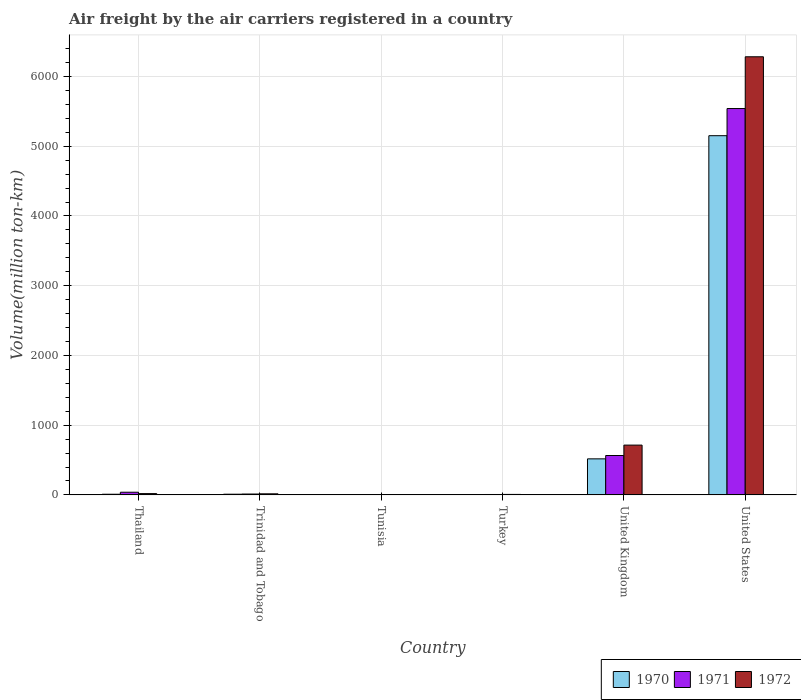How many different coloured bars are there?
Keep it short and to the point. 3. How many groups of bars are there?
Ensure brevity in your answer.  6. Are the number of bars per tick equal to the number of legend labels?
Make the answer very short. Yes. What is the label of the 3rd group of bars from the left?
Make the answer very short. Tunisia. What is the volume of the air carriers in 1971 in Trinidad and Tobago?
Provide a short and direct response. 12.6. Across all countries, what is the maximum volume of the air carriers in 1970?
Your answer should be very brief. 5151.2. Across all countries, what is the minimum volume of the air carriers in 1971?
Offer a very short reply. 1.6. In which country was the volume of the air carriers in 1972 minimum?
Give a very brief answer. Tunisia. What is the total volume of the air carriers in 1970 in the graph?
Keep it short and to the point. 5693.1. What is the difference between the volume of the air carriers in 1971 in Tunisia and that in United States?
Ensure brevity in your answer.  -5539.2. What is the difference between the volume of the air carriers in 1971 in United States and the volume of the air carriers in 1970 in Trinidad and Tobago?
Ensure brevity in your answer.  5531.1. What is the average volume of the air carriers in 1970 per country?
Give a very brief answer. 948.85. What is the difference between the volume of the air carriers of/in 1972 and volume of the air carriers of/in 1971 in United States?
Your answer should be very brief. 742.2. What is the ratio of the volume of the air carriers in 1970 in Turkey to that in United States?
Ensure brevity in your answer.  0. Is the volume of the air carriers in 1970 in Trinidad and Tobago less than that in Turkey?
Give a very brief answer. No. What is the difference between the highest and the second highest volume of the air carriers in 1972?
Your response must be concise. -695.5. What is the difference between the highest and the lowest volume of the air carriers in 1970?
Give a very brief answer. 5149.8. In how many countries, is the volume of the air carriers in 1970 greater than the average volume of the air carriers in 1970 taken over all countries?
Ensure brevity in your answer.  1. What does the 3rd bar from the right in Tunisia represents?
Keep it short and to the point. 1970. How many bars are there?
Your answer should be compact. 18. Are all the bars in the graph horizontal?
Your answer should be very brief. No. How many countries are there in the graph?
Your answer should be very brief. 6. Are the values on the major ticks of Y-axis written in scientific E-notation?
Offer a terse response. No. How are the legend labels stacked?
Your response must be concise. Horizontal. What is the title of the graph?
Your response must be concise. Air freight by the air carriers registered in a country. What is the label or title of the X-axis?
Provide a succinct answer. Country. What is the label or title of the Y-axis?
Ensure brevity in your answer.  Volume(million ton-km). What is the Volume(million ton-km) in 1970 in Thailand?
Your answer should be very brief. 9.3. What is the Volume(million ton-km) of 1971 in Thailand?
Your answer should be compact. 38.3. What is the Volume(million ton-km) in 1972 in Thailand?
Ensure brevity in your answer.  18.6. What is the Volume(million ton-km) in 1970 in Trinidad and Tobago?
Offer a very short reply. 9.7. What is the Volume(million ton-km) of 1971 in Trinidad and Tobago?
Make the answer very short. 12.6. What is the Volume(million ton-km) in 1972 in Trinidad and Tobago?
Keep it short and to the point. 15.3. What is the Volume(million ton-km) in 1970 in Tunisia?
Your response must be concise. 1.4. What is the Volume(million ton-km) of 1971 in Tunisia?
Keep it short and to the point. 1.6. What is the Volume(million ton-km) of 1972 in Tunisia?
Offer a terse response. 2.8. What is the Volume(million ton-km) of 1970 in Turkey?
Offer a terse response. 4.6. What is the Volume(million ton-km) in 1971 in Turkey?
Your response must be concise. 5.7. What is the Volume(million ton-km) in 1972 in Turkey?
Give a very brief answer. 6.8. What is the Volume(million ton-km) of 1970 in United Kingdom?
Offer a very short reply. 516.9. What is the Volume(million ton-km) of 1971 in United Kingdom?
Keep it short and to the point. 564.9. What is the Volume(million ton-km) of 1972 in United Kingdom?
Make the answer very short. 714.1. What is the Volume(million ton-km) of 1970 in United States?
Keep it short and to the point. 5151.2. What is the Volume(million ton-km) of 1971 in United States?
Ensure brevity in your answer.  5540.8. What is the Volume(million ton-km) in 1972 in United States?
Offer a very short reply. 6283. Across all countries, what is the maximum Volume(million ton-km) in 1970?
Provide a short and direct response. 5151.2. Across all countries, what is the maximum Volume(million ton-km) in 1971?
Provide a succinct answer. 5540.8. Across all countries, what is the maximum Volume(million ton-km) in 1972?
Make the answer very short. 6283. Across all countries, what is the minimum Volume(million ton-km) in 1970?
Provide a succinct answer. 1.4. Across all countries, what is the minimum Volume(million ton-km) of 1971?
Offer a terse response. 1.6. Across all countries, what is the minimum Volume(million ton-km) of 1972?
Make the answer very short. 2.8. What is the total Volume(million ton-km) in 1970 in the graph?
Your response must be concise. 5693.1. What is the total Volume(million ton-km) in 1971 in the graph?
Offer a terse response. 6163.9. What is the total Volume(million ton-km) in 1972 in the graph?
Keep it short and to the point. 7040.6. What is the difference between the Volume(million ton-km) in 1971 in Thailand and that in Trinidad and Tobago?
Your answer should be compact. 25.7. What is the difference between the Volume(million ton-km) of 1972 in Thailand and that in Trinidad and Tobago?
Your answer should be compact. 3.3. What is the difference between the Volume(million ton-km) in 1970 in Thailand and that in Tunisia?
Provide a short and direct response. 7.9. What is the difference between the Volume(million ton-km) in 1971 in Thailand and that in Tunisia?
Offer a very short reply. 36.7. What is the difference between the Volume(million ton-km) in 1970 in Thailand and that in Turkey?
Provide a short and direct response. 4.7. What is the difference between the Volume(million ton-km) of 1971 in Thailand and that in Turkey?
Provide a short and direct response. 32.6. What is the difference between the Volume(million ton-km) of 1970 in Thailand and that in United Kingdom?
Give a very brief answer. -507.6. What is the difference between the Volume(million ton-km) of 1971 in Thailand and that in United Kingdom?
Your response must be concise. -526.6. What is the difference between the Volume(million ton-km) in 1972 in Thailand and that in United Kingdom?
Make the answer very short. -695.5. What is the difference between the Volume(million ton-km) of 1970 in Thailand and that in United States?
Offer a very short reply. -5141.9. What is the difference between the Volume(million ton-km) of 1971 in Thailand and that in United States?
Provide a succinct answer. -5502.5. What is the difference between the Volume(million ton-km) in 1972 in Thailand and that in United States?
Provide a succinct answer. -6264.4. What is the difference between the Volume(million ton-km) of 1972 in Trinidad and Tobago and that in Tunisia?
Provide a short and direct response. 12.5. What is the difference between the Volume(million ton-km) in 1971 in Trinidad and Tobago and that in Turkey?
Provide a succinct answer. 6.9. What is the difference between the Volume(million ton-km) of 1972 in Trinidad and Tobago and that in Turkey?
Your answer should be compact. 8.5. What is the difference between the Volume(million ton-km) in 1970 in Trinidad and Tobago and that in United Kingdom?
Give a very brief answer. -507.2. What is the difference between the Volume(million ton-km) of 1971 in Trinidad and Tobago and that in United Kingdom?
Offer a very short reply. -552.3. What is the difference between the Volume(million ton-km) in 1972 in Trinidad and Tobago and that in United Kingdom?
Give a very brief answer. -698.8. What is the difference between the Volume(million ton-km) in 1970 in Trinidad and Tobago and that in United States?
Your answer should be very brief. -5141.5. What is the difference between the Volume(million ton-km) in 1971 in Trinidad and Tobago and that in United States?
Your answer should be very brief. -5528.2. What is the difference between the Volume(million ton-km) of 1972 in Trinidad and Tobago and that in United States?
Offer a very short reply. -6267.7. What is the difference between the Volume(million ton-km) in 1970 in Tunisia and that in Turkey?
Keep it short and to the point. -3.2. What is the difference between the Volume(million ton-km) in 1971 in Tunisia and that in Turkey?
Keep it short and to the point. -4.1. What is the difference between the Volume(million ton-km) of 1970 in Tunisia and that in United Kingdom?
Make the answer very short. -515.5. What is the difference between the Volume(million ton-km) in 1971 in Tunisia and that in United Kingdom?
Ensure brevity in your answer.  -563.3. What is the difference between the Volume(million ton-km) of 1972 in Tunisia and that in United Kingdom?
Give a very brief answer. -711.3. What is the difference between the Volume(million ton-km) in 1970 in Tunisia and that in United States?
Your response must be concise. -5149.8. What is the difference between the Volume(million ton-km) in 1971 in Tunisia and that in United States?
Ensure brevity in your answer.  -5539.2. What is the difference between the Volume(million ton-km) of 1972 in Tunisia and that in United States?
Give a very brief answer. -6280.2. What is the difference between the Volume(million ton-km) of 1970 in Turkey and that in United Kingdom?
Give a very brief answer. -512.3. What is the difference between the Volume(million ton-km) in 1971 in Turkey and that in United Kingdom?
Provide a succinct answer. -559.2. What is the difference between the Volume(million ton-km) of 1972 in Turkey and that in United Kingdom?
Offer a very short reply. -707.3. What is the difference between the Volume(million ton-km) in 1970 in Turkey and that in United States?
Provide a succinct answer. -5146.6. What is the difference between the Volume(million ton-km) in 1971 in Turkey and that in United States?
Your response must be concise. -5535.1. What is the difference between the Volume(million ton-km) of 1972 in Turkey and that in United States?
Make the answer very short. -6276.2. What is the difference between the Volume(million ton-km) of 1970 in United Kingdom and that in United States?
Ensure brevity in your answer.  -4634.3. What is the difference between the Volume(million ton-km) in 1971 in United Kingdom and that in United States?
Ensure brevity in your answer.  -4975.9. What is the difference between the Volume(million ton-km) in 1972 in United Kingdom and that in United States?
Provide a succinct answer. -5568.9. What is the difference between the Volume(million ton-km) in 1971 in Thailand and the Volume(million ton-km) in 1972 in Trinidad and Tobago?
Your response must be concise. 23. What is the difference between the Volume(million ton-km) in 1970 in Thailand and the Volume(million ton-km) in 1972 in Tunisia?
Your response must be concise. 6.5. What is the difference between the Volume(million ton-km) in 1971 in Thailand and the Volume(million ton-km) in 1972 in Tunisia?
Your answer should be compact. 35.5. What is the difference between the Volume(million ton-km) of 1970 in Thailand and the Volume(million ton-km) of 1971 in Turkey?
Your response must be concise. 3.6. What is the difference between the Volume(million ton-km) of 1971 in Thailand and the Volume(million ton-km) of 1972 in Turkey?
Offer a terse response. 31.5. What is the difference between the Volume(million ton-km) in 1970 in Thailand and the Volume(million ton-km) in 1971 in United Kingdom?
Provide a short and direct response. -555.6. What is the difference between the Volume(million ton-km) in 1970 in Thailand and the Volume(million ton-km) in 1972 in United Kingdom?
Your answer should be very brief. -704.8. What is the difference between the Volume(million ton-km) of 1971 in Thailand and the Volume(million ton-km) of 1972 in United Kingdom?
Provide a succinct answer. -675.8. What is the difference between the Volume(million ton-km) of 1970 in Thailand and the Volume(million ton-km) of 1971 in United States?
Ensure brevity in your answer.  -5531.5. What is the difference between the Volume(million ton-km) of 1970 in Thailand and the Volume(million ton-km) of 1972 in United States?
Provide a succinct answer. -6273.7. What is the difference between the Volume(million ton-km) in 1971 in Thailand and the Volume(million ton-km) in 1972 in United States?
Make the answer very short. -6244.7. What is the difference between the Volume(million ton-km) in 1971 in Trinidad and Tobago and the Volume(million ton-km) in 1972 in Turkey?
Provide a short and direct response. 5.8. What is the difference between the Volume(million ton-km) in 1970 in Trinidad and Tobago and the Volume(million ton-km) in 1971 in United Kingdom?
Keep it short and to the point. -555.2. What is the difference between the Volume(million ton-km) of 1970 in Trinidad and Tobago and the Volume(million ton-km) of 1972 in United Kingdom?
Ensure brevity in your answer.  -704.4. What is the difference between the Volume(million ton-km) in 1971 in Trinidad and Tobago and the Volume(million ton-km) in 1972 in United Kingdom?
Provide a succinct answer. -701.5. What is the difference between the Volume(million ton-km) of 1970 in Trinidad and Tobago and the Volume(million ton-km) of 1971 in United States?
Your response must be concise. -5531.1. What is the difference between the Volume(million ton-km) in 1970 in Trinidad and Tobago and the Volume(million ton-km) in 1972 in United States?
Give a very brief answer. -6273.3. What is the difference between the Volume(million ton-km) of 1971 in Trinidad and Tobago and the Volume(million ton-km) of 1972 in United States?
Provide a succinct answer. -6270.4. What is the difference between the Volume(million ton-km) in 1970 in Tunisia and the Volume(million ton-km) in 1972 in Turkey?
Give a very brief answer. -5.4. What is the difference between the Volume(million ton-km) of 1970 in Tunisia and the Volume(million ton-km) of 1971 in United Kingdom?
Your answer should be very brief. -563.5. What is the difference between the Volume(million ton-km) of 1970 in Tunisia and the Volume(million ton-km) of 1972 in United Kingdom?
Your answer should be compact. -712.7. What is the difference between the Volume(million ton-km) in 1971 in Tunisia and the Volume(million ton-km) in 1972 in United Kingdom?
Your answer should be very brief. -712.5. What is the difference between the Volume(million ton-km) of 1970 in Tunisia and the Volume(million ton-km) of 1971 in United States?
Ensure brevity in your answer.  -5539.4. What is the difference between the Volume(million ton-km) of 1970 in Tunisia and the Volume(million ton-km) of 1972 in United States?
Make the answer very short. -6281.6. What is the difference between the Volume(million ton-km) in 1971 in Tunisia and the Volume(million ton-km) in 1972 in United States?
Offer a very short reply. -6281.4. What is the difference between the Volume(million ton-km) in 1970 in Turkey and the Volume(million ton-km) in 1971 in United Kingdom?
Provide a succinct answer. -560.3. What is the difference between the Volume(million ton-km) of 1970 in Turkey and the Volume(million ton-km) of 1972 in United Kingdom?
Give a very brief answer. -709.5. What is the difference between the Volume(million ton-km) in 1971 in Turkey and the Volume(million ton-km) in 1972 in United Kingdom?
Give a very brief answer. -708.4. What is the difference between the Volume(million ton-km) of 1970 in Turkey and the Volume(million ton-km) of 1971 in United States?
Your answer should be very brief. -5536.2. What is the difference between the Volume(million ton-km) in 1970 in Turkey and the Volume(million ton-km) in 1972 in United States?
Keep it short and to the point. -6278.4. What is the difference between the Volume(million ton-km) of 1971 in Turkey and the Volume(million ton-km) of 1972 in United States?
Provide a short and direct response. -6277.3. What is the difference between the Volume(million ton-km) in 1970 in United Kingdom and the Volume(million ton-km) in 1971 in United States?
Provide a short and direct response. -5023.9. What is the difference between the Volume(million ton-km) in 1970 in United Kingdom and the Volume(million ton-km) in 1972 in United States?
Your answer should be very brief. -5766.1. What is the difference between the Volume(million ton-km) of 1971 in United Kingdom and the Volume(million ton-km) of 1972 in United States?
Your answer should be very brief. -5718.1. What is the average Volume(million ton-km) of 1970 per country?
Your answer should be very brief. 948.85. What is the average Volume(million ton-km) in 1971 per country?
Your answer should be very brief. 1027.32. What is the average Volume(million ton-km) of 1972 per country?
Offer a terse response. 1173.43. What is the difference between the Volume(million ton-km) of 1971 and Volume(million ton-km) of 1972 in Thailand?
Your answer should be very brief. 19.7. What is the difference between the Volume(million ton-km) of 1970 and Volume(million ton-km) of 1971 in Trinidad and Tobago?
Provide a succinct answer. -2.9. What is the difference between the Volume(million ton-km) of 1970 and Volume(million ton-km) of 1972 in Trinidad and Tobago?
Your answer should be compact. -5.6. What is the difference between the Volume(million ton-km) in 1970 and Volume(million ton-km) in 1972 in Turkey?
Offer a very short reply. -2.2. What is the difference between the Volume(million ton-km) of 1970 and Volume(million ton-km) of 1971 in United Kingdom?
Provide a short and direct response. -48. What is the difference between the Volume(million ton-km) of 1970 and Volume(million ton-km) of 1972 in United Kingdom?
Keep it short and to the point. -197.2. What is the difference between the Volume(million ton-km) of 1971 and Volume(million ton-km) of 1972 in United Kingdom?
Keep it short and to the point. -149.2. What is the difference between the Volume(million ton-km) in 1970 and Volume(million ton-km) in 1971 in United States?
Provide a short and direct response. -389.6. What is the difference between the Volume(million ton-km) of 1970 and Volume(million ton-km) of 1972 in United States?
Ensure brevity in your answer.  -1131.8. What is the difference between the Volume(million ton-km) of 1971 and Volume(million ton-km) of 1972 in United States?
Keep it short and to the point. -742.2. What is the ratio of the Volume(million ton-km) in 1970 in Thailand to that in Trinidad and Tobago?
Give a very brief answer. 0.96. What is the ratio of the Volume(million ton-km) of 1971 in Thailand to that in Trinidad and Tobago?
Your answer should be compact. 3.04. What is the ratio of the Volume(million ton-km) in 1972 in Thailand to that in Trinidad and Tobago?
Give a very brief answer. 1.22. What is the ratio of the Volume(million ton-km) in 1970 in Thailand to that in Tunisia?
Give a very brief answer. 6.64. What is the ratio of the Volume(million ton-km) of 1971 in Thailand to that in Tunisia?
Your answer should be compact. 23.94. What is the ratio of the Volume(million ton-km) of 1972 in Thailand to that in Tunisia?
Offer a very short reply. 6.64. What is the ratio of the Volume(million ton-km) of 1970 in Thailand to that in Turkey?
Your answer should be very brief. 2.02. What is the ratio of the Volume(million ton-km) in 1971 in Thailand to that in Turkey?
Provide a succinct answer. 6.72. What is the ratio of the Volume(million ton-km) of 1972 in Thailand to that in Turkey?
Offer a very short reply. 2.74. What is the ratio of the Volume(million ton-km) of 1970 in Thailand to that in United Kingdom?
Ensure brevity in your answer.  0.02. What is the ratio of the Volume(million ton-km) of 1971 in Thailand to that in United Kingdom?
Offer a very short reply. 0.07. What is the ratio of the Volume(million ton-km) of 1972 in Thailand to that in United Kingdom?
Your answer should be compact. 0.03. What is the ratio of the Volume(million ton-km) of 1970 in Thailand to that in United States?
Ensure brevity in your answer.  0. What is the ratio of the Volume(million ton-km) in 1971 in Thailand to that in United States?
Ensure brevity in your answer.  0.01. What is the ratio of the Volume(million ton-km) of 1972 in Thailand to that in United States?
Provide a succinct answer. 0. What is the ratio of the Volume(million ton-km) in 1970 in Trinidad and Tobago to that in Tunisia?
Your answer should be compact. 6.93. What is the ratio of the Volume(million ton-km) in 1971 in Trinidad and Tobago to that in Tunisia?
Keep it short and to the point. 7.88. What is the ratio of the Volume(million ton-km) in 1972 in Trinidad and Tobago to that in Tunisia?
Provide a short and direct response. 5.46. What is the ratio of the Volume(million ton-km) of 1970 in Trinidad and Tobago to that in Turkey?
Offer a terse response. 2.11. What is the ratio of the Volume(million ton-km) in 1971 in Trinidad and Tobago to that in Turkey?
Provide a succinct answer. 2.21. What is the ratio of the Volume(million ton-km) in 1972 in Trinidad and Tobago to that in Turkey?
Your response must be concise. 2.25. What is the ratio of the Volume(million ton-km) of 1970 in Trinidad and Tobago to that in United Kingdom?
Your answer should be compact. 0.02. What is the ratio of the Volume(million ton-km) in 1971 in Trinidad and Tobago to that in United Kingdom?
Keep it short and to the point. 0.02. What is the ratio of the Volume(million ton-km) of 1972 in Trinidad and Tobago to that in United Kingdom?
Offer a terse response. 0.02. What is the ratio of the Volume(million ton-km) in 1970 in Trinidad and Tobago to that in United States?
Keep it short and to the point. 0. What is the ratio of the Volume(million ton-km) of 1971 in Trinidad and Tobago to that in United States?
Keep it short and to the point. 0. What is the ratio of the Volume(million ton-km) of 1972 in Trinidad and Tobago to that in United States?
Provide a short and direct response. 0. What is the ratio of the Volume(million ton-km) in 1970 in Tunisia to that in Turkey?
Provide a succinct answer. 0.3. What is the ratio of the Volume(million ton-km) of 1971 in Tunisia to that in Turkey?
Give a very brief answer. 0.28. What is the ratio of the Volume(million ton-km) in 1972 in Tunisia to that in Turkey?
Your answer should be compact. 0.41. What is the ratio of the Volume(million ton-km) in 1970 in Tunisia to that in United Kingdom?
Keep it short and to the point. 0. What is the ratio of the Volume(million ton-km) in 1971 in Tunisia to that in United Kingdom?
Provide a short and direct response. 0. What is the ratio of the Volume(million ton-km) in 1972 in Tunisia to that in United Kingdom?
Your response must be concise. 0. What is the ratio of the Volume(million ton-km) in 1970 in Turkey to that in United Kingdom?
Your answer should be compact. 0.01. What is the ratio of the Volume(million ton-km) of 1971 in Turkey to that in United Kingdom?
Provide a short and direct response. 0.01. What is the ratio of the Volume(million ton-km) of 1972 in Turkey to that in United Kingdom?
Your answer should be compact. 0.01. What is the ratio of the Volume(million ton-km) of 1970 in Turkey to that in United States?
Give a very brief answer. 0. What is the ratio of the Volume(million ton-km) in 1972 in Turkey to that in United States?
Provide a short and direct response. 0. What is the ratio of the Volume(million ton-km) of 1970 in United Kingdom to that in United States?
Offer a terse response. 0.1. What is the ratio of the Volume(million ton-km) in 1971 in United Kingdom to that in United States?
Ensure brevity in your answer.  0.1. What is the ratio of the Volume(million ton-km) of 1972 in United Kingdom to that in United States?
Provide a short and direct response. 0.11. What is the difference between the highest and the second highest Volume(million ton-km) in 1970?
Keep it short and to the point. 4634.3. What is the difference between the highest and the second highest Volume(million ton-km) of 1971?
Offer a terse response. 4975.9. What is the difference between the highest and the second highest Volume(million ton-km) of 1972?
Offer a terse response. 5568.9. What is the difference between the highest and the lowest Volume(million ton-km) of 1970?
Ensure brevity in your answer.  5149.8. What is the difference between the highest and the lowest Volume(million ton-km) in 1971?
Your response must be concise. 5539.2. What is the difference between the highest and the lowest Volume(million ton-km) in 1972?
Provide a succinct answer. 6280.2. 